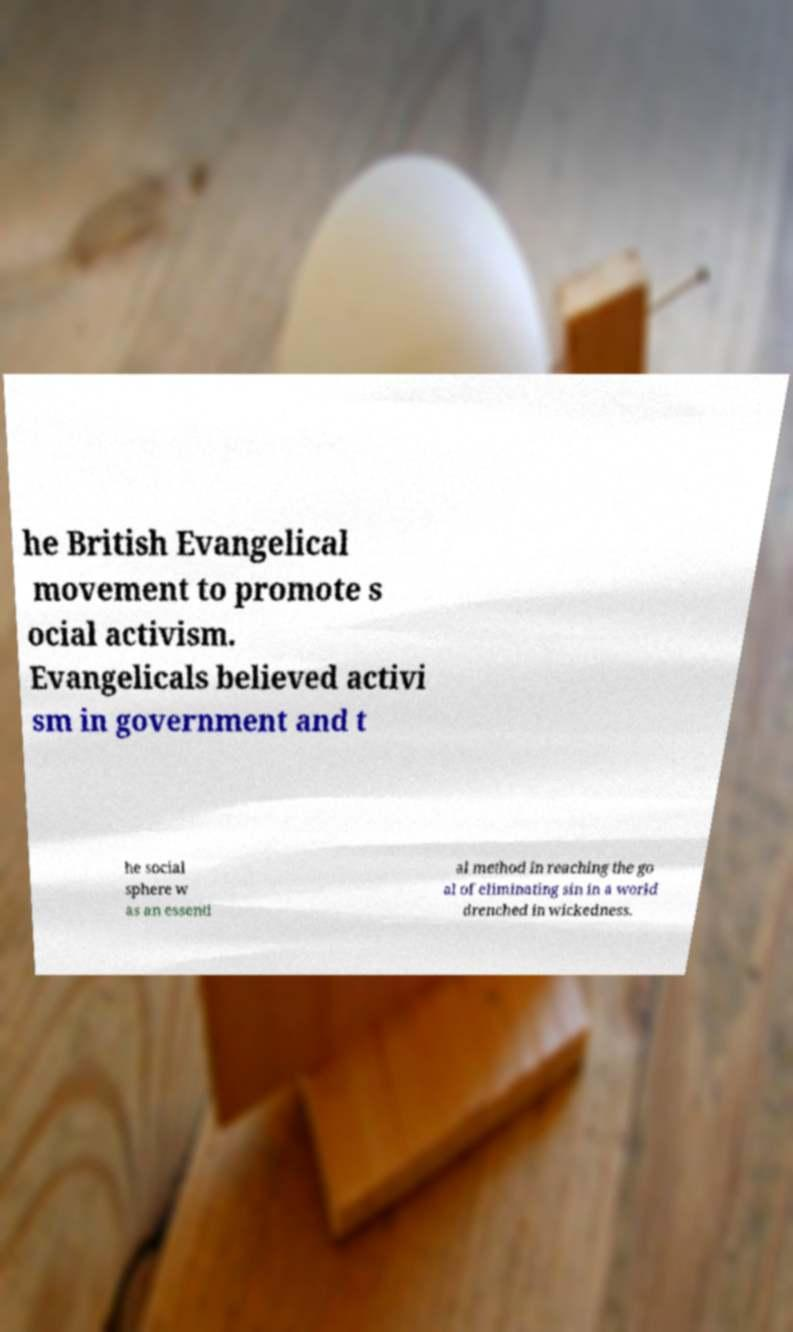There's text embedded in this image that I need extracted. Can you transcribe it verbatim? he British Evangelical movement to promote s ocial activism. Evangelicals believed activi sm in government and t he social sphere w as an essenti al method in reaching the go al of eliminating sin in a world drenched in wickedness. 